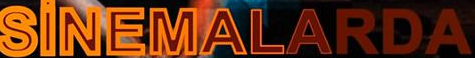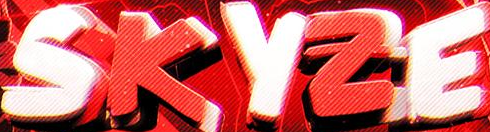What words can you see in these images in sequence, separated by a semicolon? SiNEMALARDA; SKYZE 